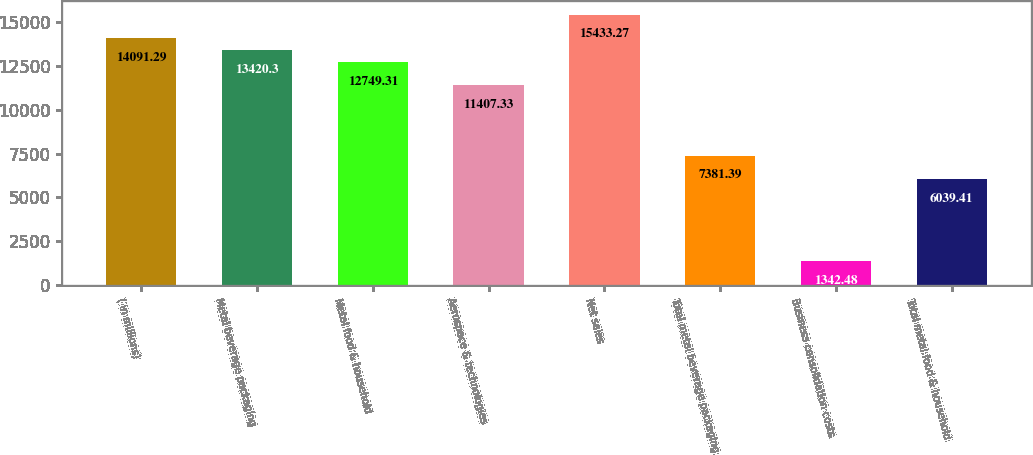<chart> <loc_0><loc_0><loc_500><loc_500><bar_chart><fcel>( in millions)<fcel>Metal beverage packaging<fcel>Metal food & household<fcel>Aerospace & technologies<fcel>Net sales<fcel>Total metal beverage packaging<fcel>Business consolidation costs<fcel>Total metal food & household<nl><fcel>14091.3<fcel>13420.3<fcel>12749.3<fcel>11407.3<fcel>15433.3<fcel>7381.39<fcel>1342.48<fcel>6039.41<nl></chart> 